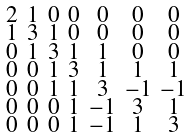<formula> <loc_0><loc_0><loc_500><loc_500>\begin{smallmatrix} 2 & 1 & 0 & 0 & 0 & 0 & 0 \\ 1 & 3 & 1 & 0 & 0 & 0 & 0 \\ 0 & 1 & 3 & 1 & 1 & 0 & 0 \\ 0 & 0 & 1 & 3 & 1 & 1 & 1 \\ 0 & 0 & 1 & 1 & 3 & - 1 & - 1 \\ 0 & 0 & 0 & 1 & - 1 & 3 & 1 \\ 0 & 0 & 0 & 1 & - 1 & 1 & 3 \end{smallmatrix}</formula> 